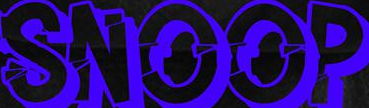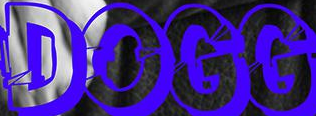Identify the words shown in these images in order, separated by a semicolon. SNOOP; DOGG 